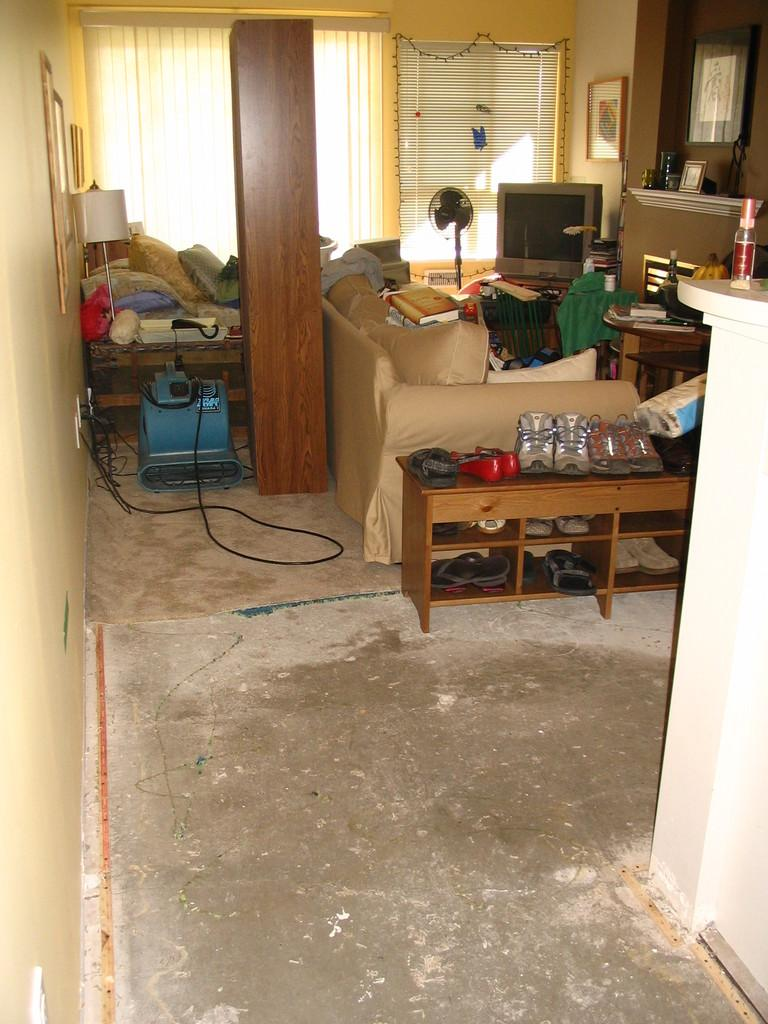Where was the image taken? The image was taken in a room. What furniture is present in the room? There is a sofa in the room. What electronic device is in the room? There is a television in the room. What is used for storing shoes in the room? There is a shoe rack in the room. What is used for providing light in the room? There is a lamp in the room. What is used for displaying a photo in the room? There is a photo frame in the room. What is used for providing air circulation in the room? There is a table fan in the room. What is the container in the room? There is a bottle in the room. What allows natural light to enter the room? There are windows in the room. Who is the creator of the camera used to take the image? There is no camera mentioned in the image, so it is not possible to determine who created the camera used to take the image. 